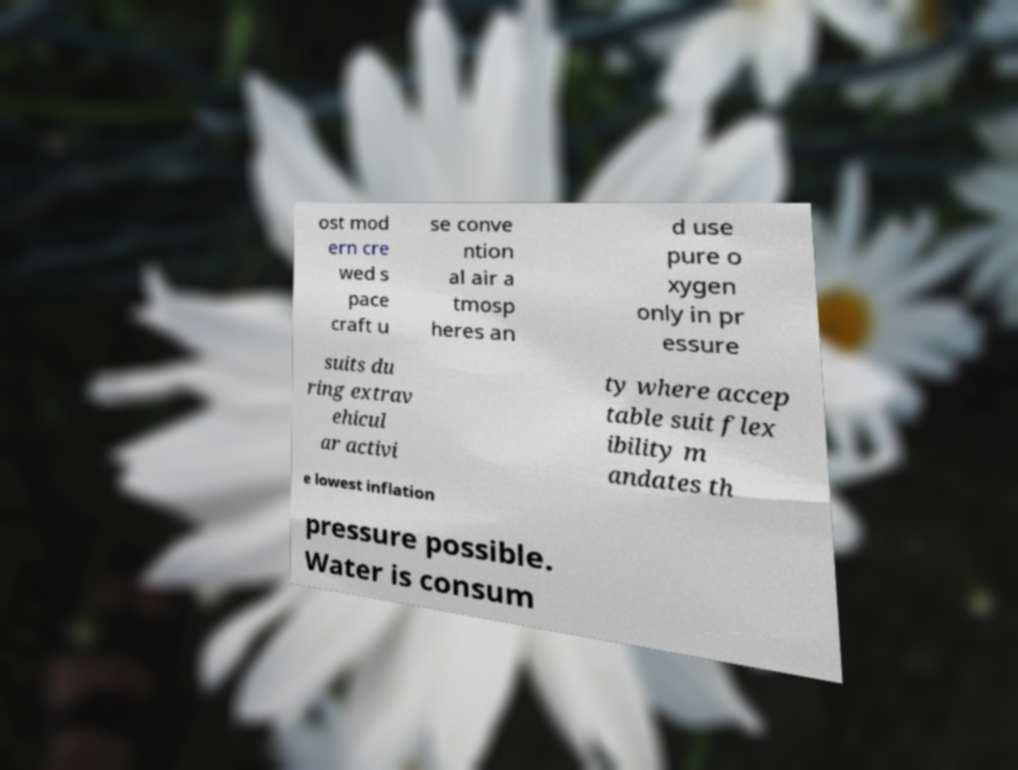Please identify and transcribe the text found in this image. ost mod ern cre wed s pace craft u se conve ntion al air a tmosp heres an d use pure o xygen only in pr essure suits du ring extrav ehicul ar activi ty where accep table suit flex ibility m andates th e lowest inflation pressure possible. Water is consum 